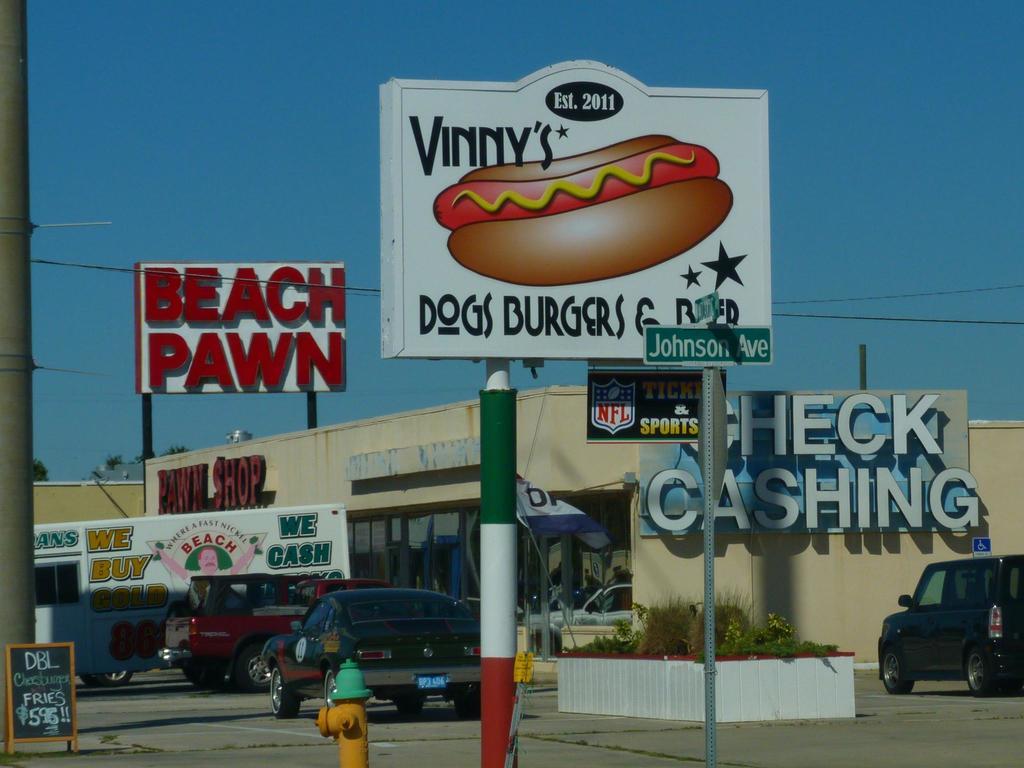What is the pawn shop called?
Keep it short and to the point. Beach pawn. 